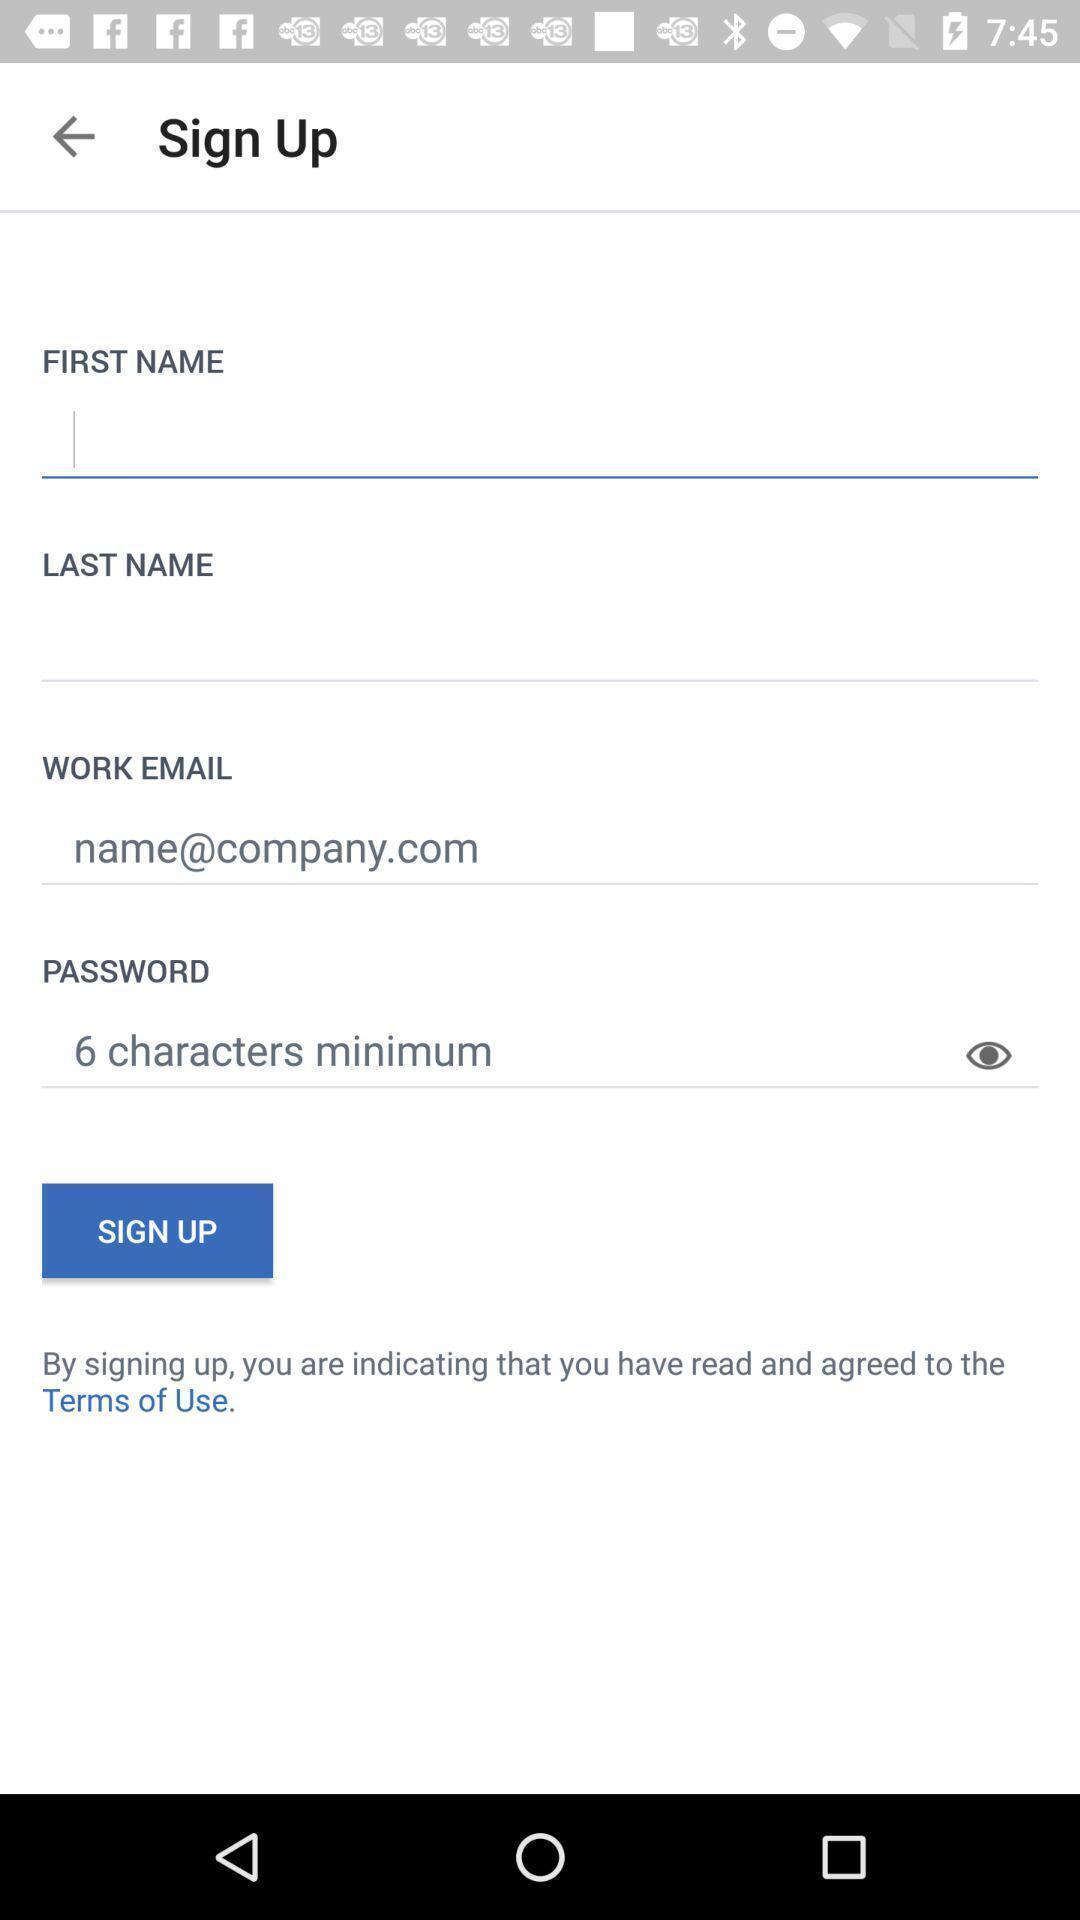Provide a description of this screenshot. Sign up page. 